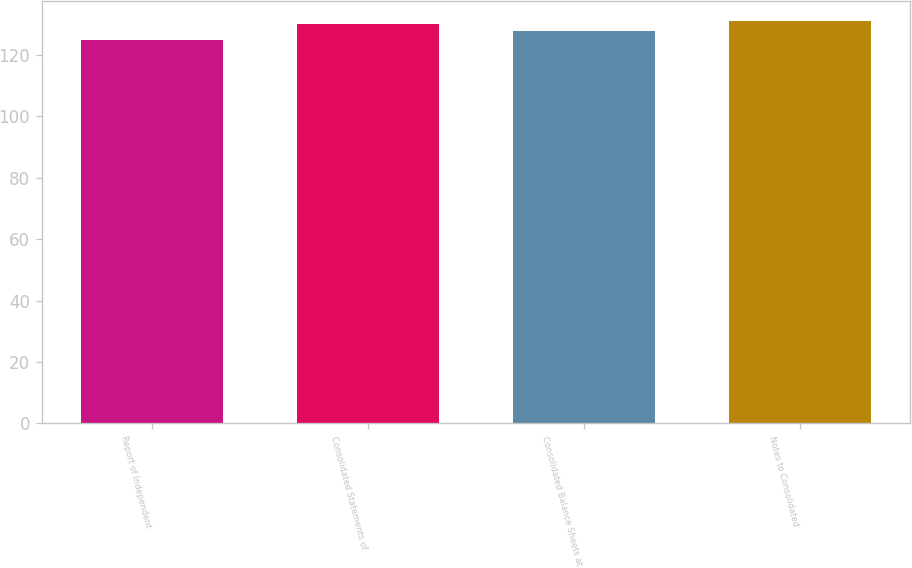Convert chart. <chart><loc_0><loc_0><loc_500><loc_500><bar_chart><fcel>Report of Independent<fcel>Consolidated Statements of<fcel>Consolidated Balance Sheets at<fcel>Notes to Consolidated<nl><fcel>125<fcel>130<fcel>128<fcel>131<nl></chart> 